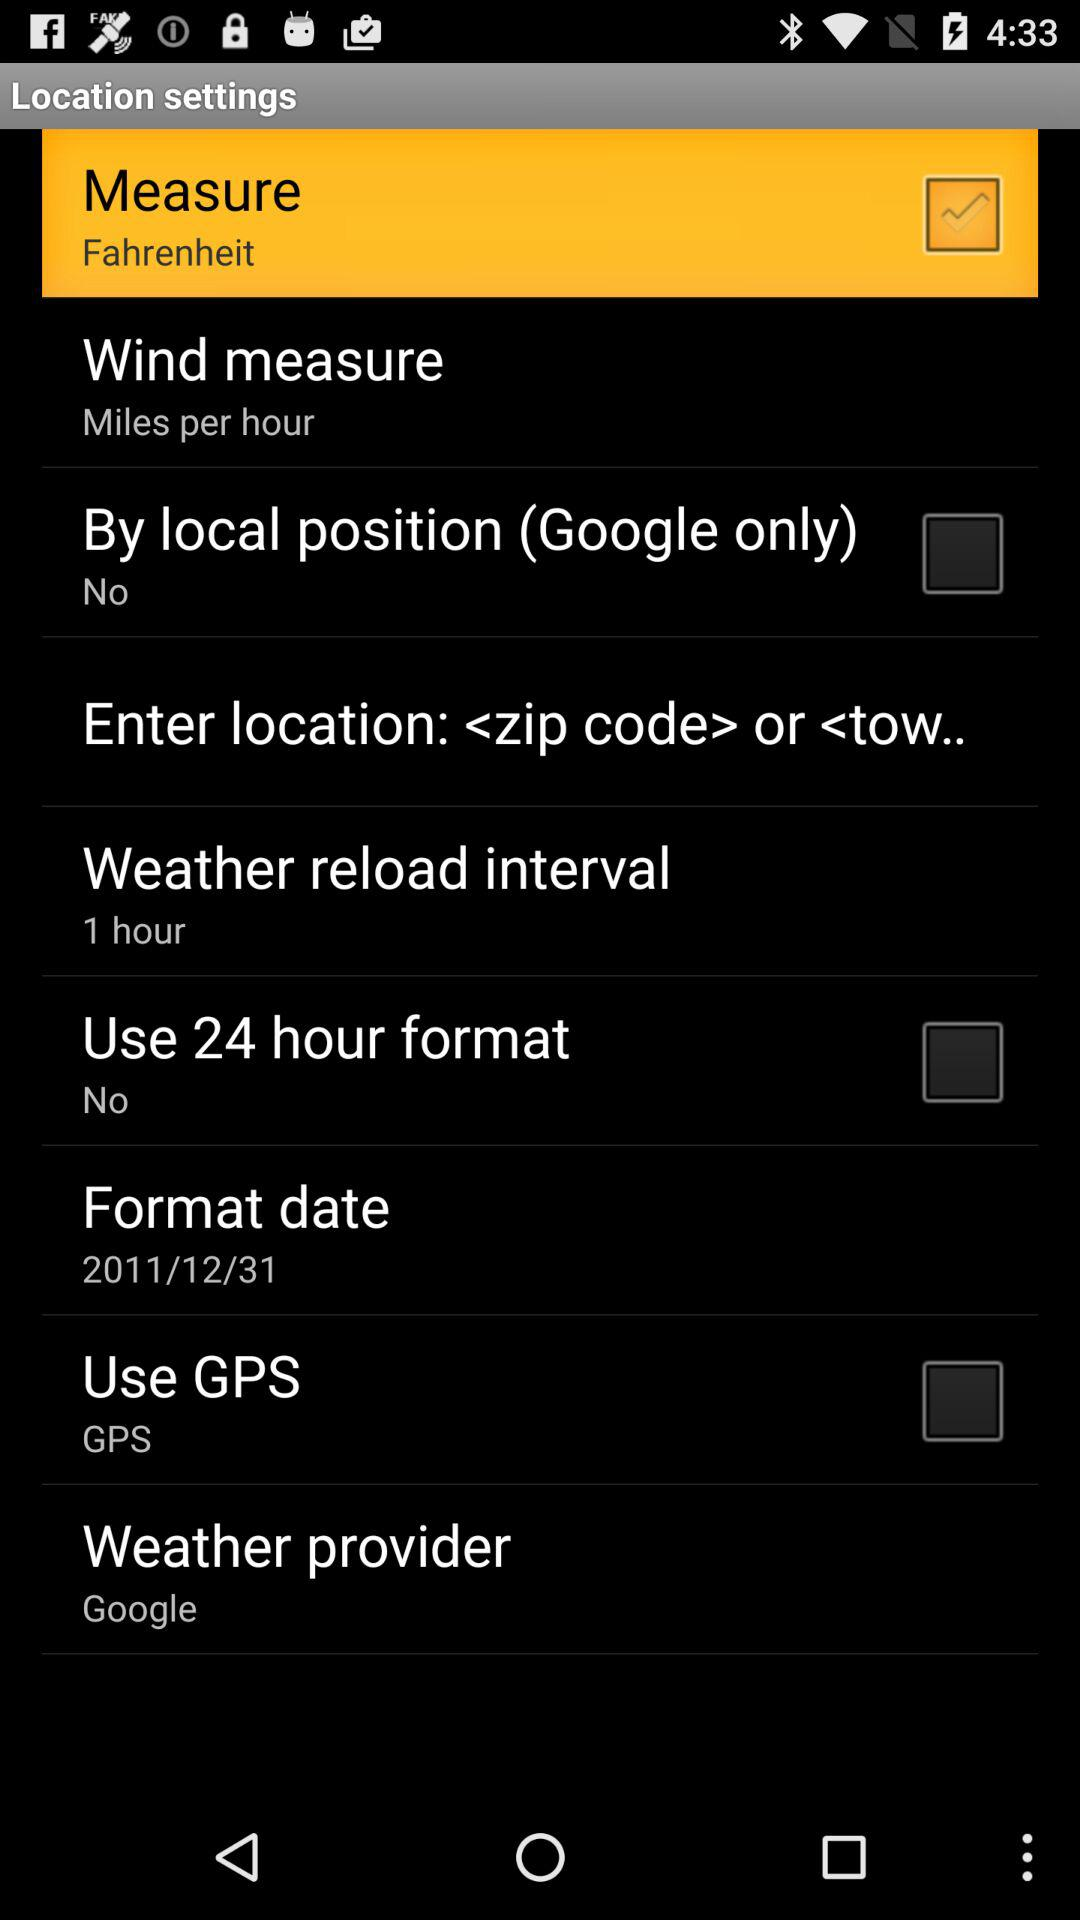What is the status of "Use GPS"? The status of "Use GPS" is "off". 